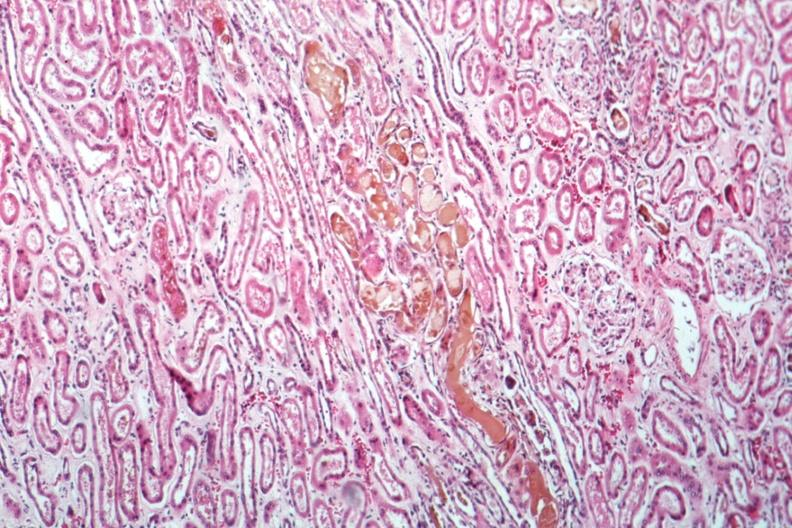what does this image show?
Answer the question using a single word or phrase. Bile nephrosis very good example 